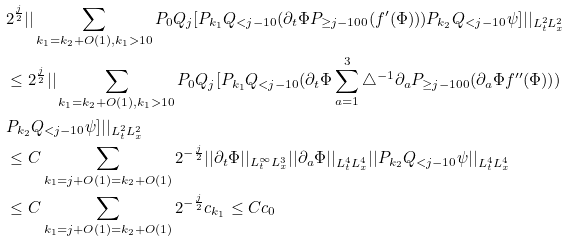Convert formula to latex. <formula><loc_0><loc_0><loc_500><loc_500>& 2 ^ { \frac { j } { 2 } } | | \sum _ { k _ { 1 } = k _ { 2 } + O ( 1 ) , k _ { 1 } > 1 0 } P _ { 0 } Q _ { j } [ P _ { k _ { 1 } } Q _ { < j - 1 0 } ( \partial _ { t } \Phi P _ { \geq j - 1 0 0 } ( f ^ { \prime } ( \Phi ) ) ) P _ { k _ { 2 } } Q _ { < j - 1 0 } \psi ] | | _ { L _ { t } ^ { 2 } L _ { x } ^ { 2 } } \\ & \leq 2 ^ { \frac { j } { 2 } } | | \sum _ { k _ { 1 } = k _ { 2 } + O ( 1 ) , k _ { 1 } > 1 0 } P _ { 0 } Q _ { j } [ P _ { k _ { 1 } } Q _ { < j - 1 0 } ( \partial _ { t } \Phi \sum _ { a = 1 } ^ { 3 } \triangle ^ { - 1 } \partial _ { a } P _ { \geq j - 1 0 0 } ( \partial _ { a } \Phi f ^ { \prime \prime } ( \Phi ) ) ) \\ & P _ { k _ { 2 } } Q _ { < j - 1 0 } \psi ] | | _ { L _ { t } ^ { 2 } L _ { x } ^ { 2 } } \\ & \leq C \sum _ { k _ { 1 } = j + O ( 1 ) = k _ { 2 } + O ( 1 ) } 2 ^ { - \frac { j } { 2 } } | | \partial _ { t } \Phi | | _ { L _ { t } ^ { \infty } L _ { x } ^ { 3 } } | | \partial _ { a } \Phi | | _ { L _ { t } ^ { 4 } L _ { x } ^ { 4 } } | | P _ { k _ { 2 } } Q _ { < j - 1 0 } \psi | | _ { L _ { t } ^ { 4 } L _ { x } ^ { 4 } } \\ & \leq C \sum _ { k _ { 1 } = j + O ( 1 ) = k _ { 2 } + O ( 1 ) } 2 ^ { - \frac { j } { 2 } } c _ { k _ { 1 } } \leq C c _ { 0 } \\</formula> 